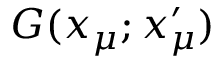Convert formula to latex. <formula><loc_0><loc_0><loc_500><loc_500>G ( x _ { \mu } ; x _ { \mu } ^ { \prime } )</formula> 